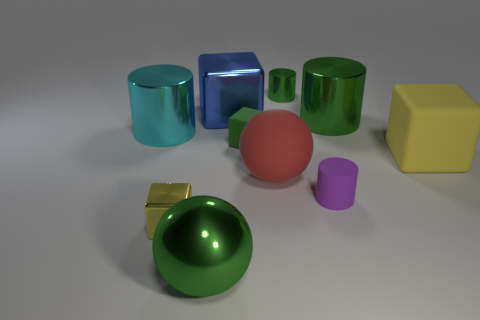What is the material of the sphere that is the same color as the small rubber cube?
Your response must be concise. Metal. How many matte things are the same color as the shiny ball?
Provide a succinct answer. 1. Are there any small rubber objects of the same color as the metallic sphere?
Keep it short and to the point. Yes. How many other objects are there of the same material as the cyan object?
Offer a terse response. 5. There is a shiny sphere; does it have the same color as the tiny cube that is behind the large yellow block?
Offer a very short reply. Yes. Are there more purple matte cylinders that are to the left of the yellow rubber block than large purple metallic blocks?
Offer a very short reply. Yes. What number of big cyan shiny cylinders are to the right of the cylinder behind the big shiny cylinder that is right of the blue shiny block?
Offer a terse response. 0. Does the big green shiny thing that is right of the green shiny sphere have the same shape as the large blue thing?
Make the answer very short. No. There is a yellow thing that is behind the tiny yellow metallic object; what is it made of?
Provide a succinct answer. Rubber. What shape is the big object that is on the right side of the green block and behind the green rubber block?
Provide a succinct answer. Cylinder. 